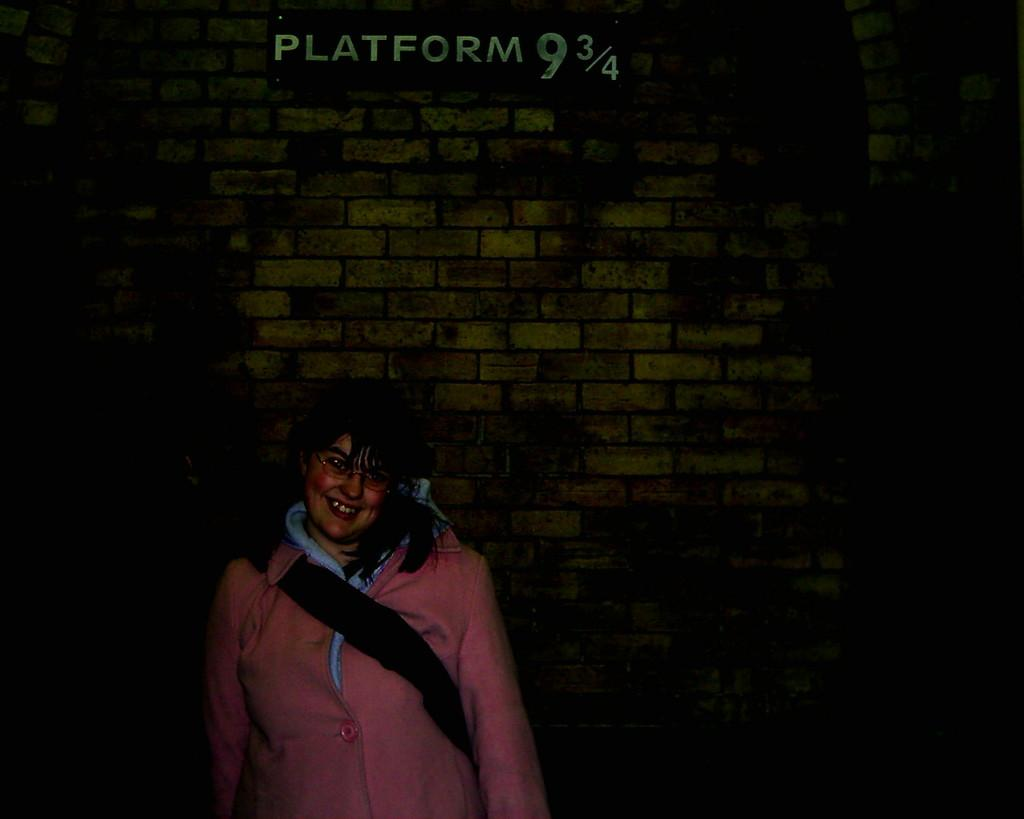Who is present in the image? There is a woman in the image. What is the woman wearing on her face? The woman is wearing spectacles. What type of clothing is the woman wearing on her upper body? The woman is wearing a jacket. What is the woman doing in the image? The woman is standing and smiling. What can be seen on the wall in the background of the image? There is a name board on the wall in the background of the image. What is the weight of the hen in the image? There is no hen present in the image, so it is not possible to determine its weight. 